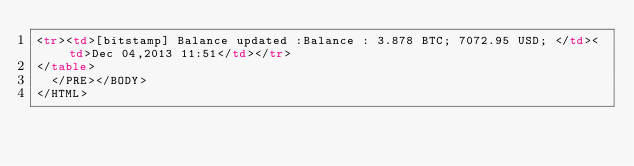<code> <loc_0><loc_0><loc_500><loc_500><_HTML_><tr><td>[bitstamp] Balance updated :Balance : 3.878 BTC; 7072.95 USD; </td><td>Dec 04,2013 11:51</td></tr>
</table>
  </PRE></BODY>
</HTML>
</code> 